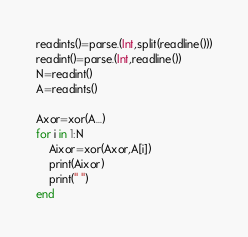Convert code to text. <code><loc_0><loc_0><loc_500><loc_500><_Julia_>readints()=parse.(Int,split(readline()))
readint()=parse.(Int,readline())
N=readint()
A=readints()

Axor=xor(A...)
for i in 1:N
    Aixor=xor(Axor,A[i])
    print(Aixor)
    print(" ")
end</code> 